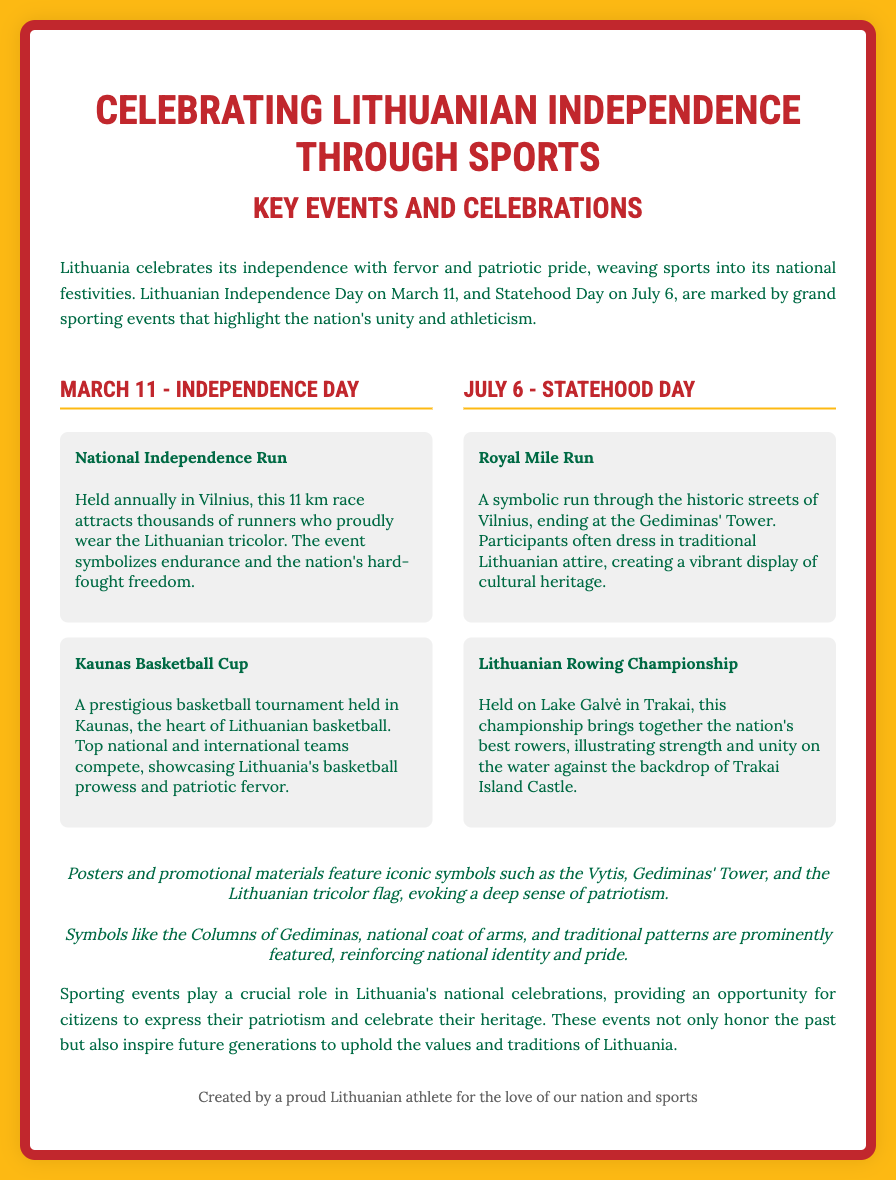What is the main theme of the poster? The main theme highlights Lithuania's celebration of independence through various sporting events and patriotic imagery.
Answer: Celebrating Lithuanian Independence through Sports When is Lithuanian Independence Day? The event is specifically noted in the document and is a national holiday celebrated annually.
Answer: March 11 What is the distance of the National Independence Run? The document specifies the length of the race held in Vilnius during Independence Day celebrations.
Answer: 11 km What event takes place on Statehood Day? The document lists notable events for this day and specifies a significant sporting event.
Answer: Lithuanian Rowing Championship Where is the Lithuanian Rowing Championship held? The location of the championship is specified in the document, linking it to a famous site.
Answer: Lake Galvė in Trakai Which emblem is mentioned as a symbol of Lithuania? The document references specific emblems used in posters, showcasing national pride.
Answer: Vytis What type of attire do participants wear in the Royal Mile Run? The description of the event indicates a cultural aspect of the attire worn by participants.
Answer: Traditional Lithuanian attire How does the poster convey a sense of patriotism? The qualities of the imagery and symbols are highlighted in the poster's narrative, showcasing national pride.
Answer: Through symbols and traditional patterns 